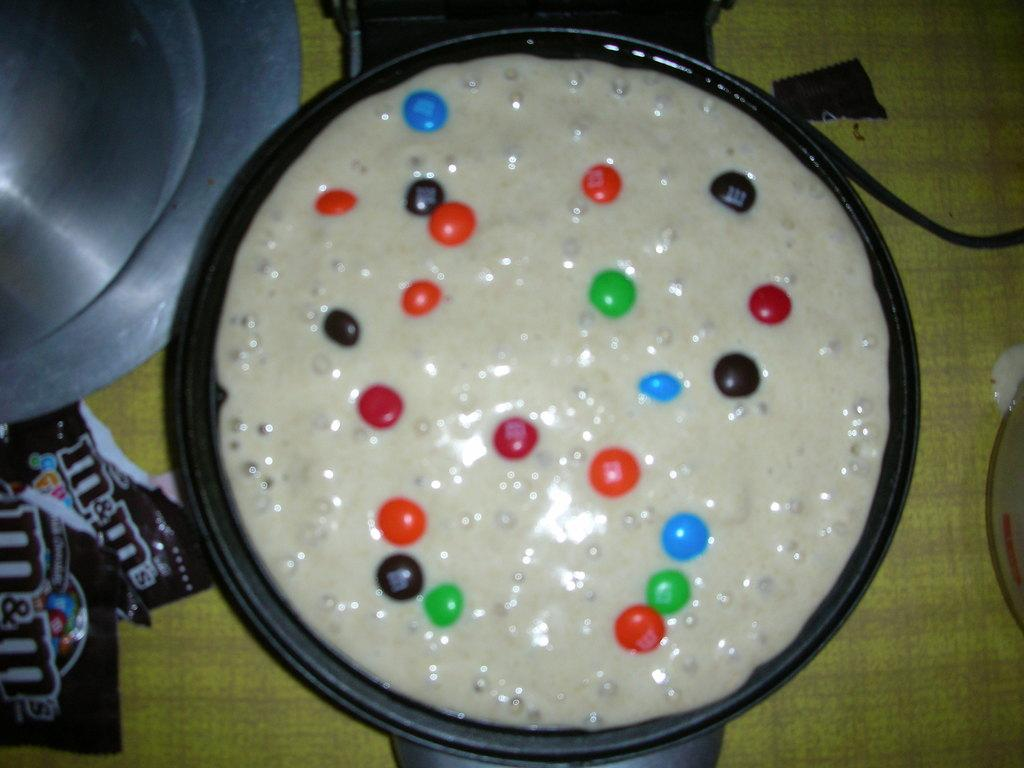What is being cooked or prepared in the pan in the image? The facts do not specify the type of food in the pan, but there is food in a pan in the image. What can be seen on the left side of the image? There are plastic covers on the left side of the image. What type of machine is being used to sing a song in the image? There is no machine or song present in the image; it only features food in a pan and plastic covers. 